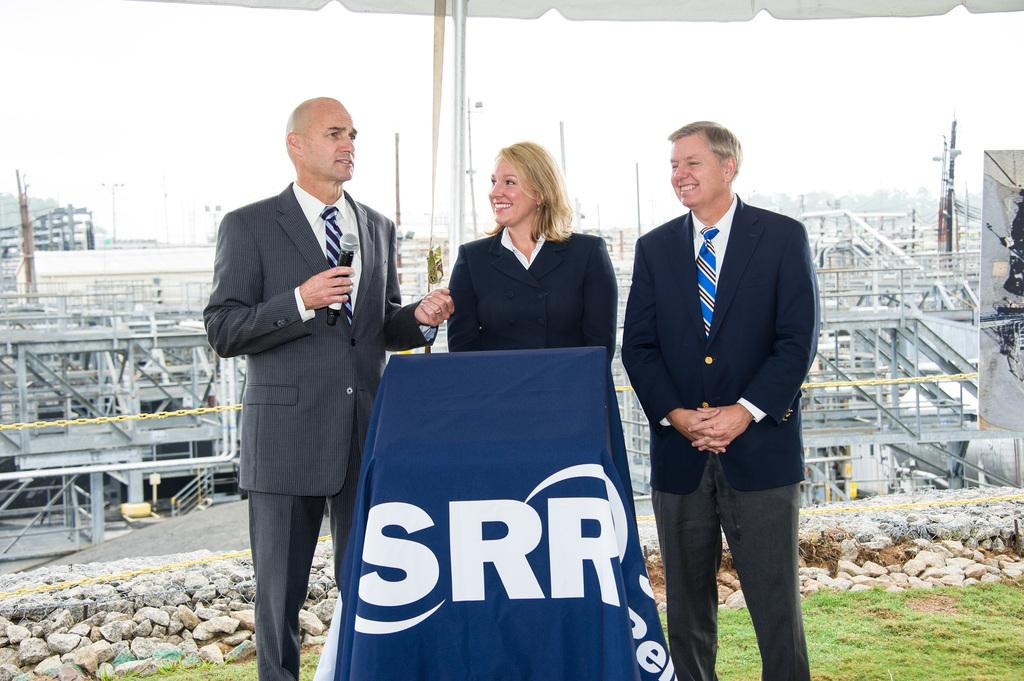<image>
Write a terse but informative summary of the picture. Two men and a woman stand behind a podium with SRR across the front. 